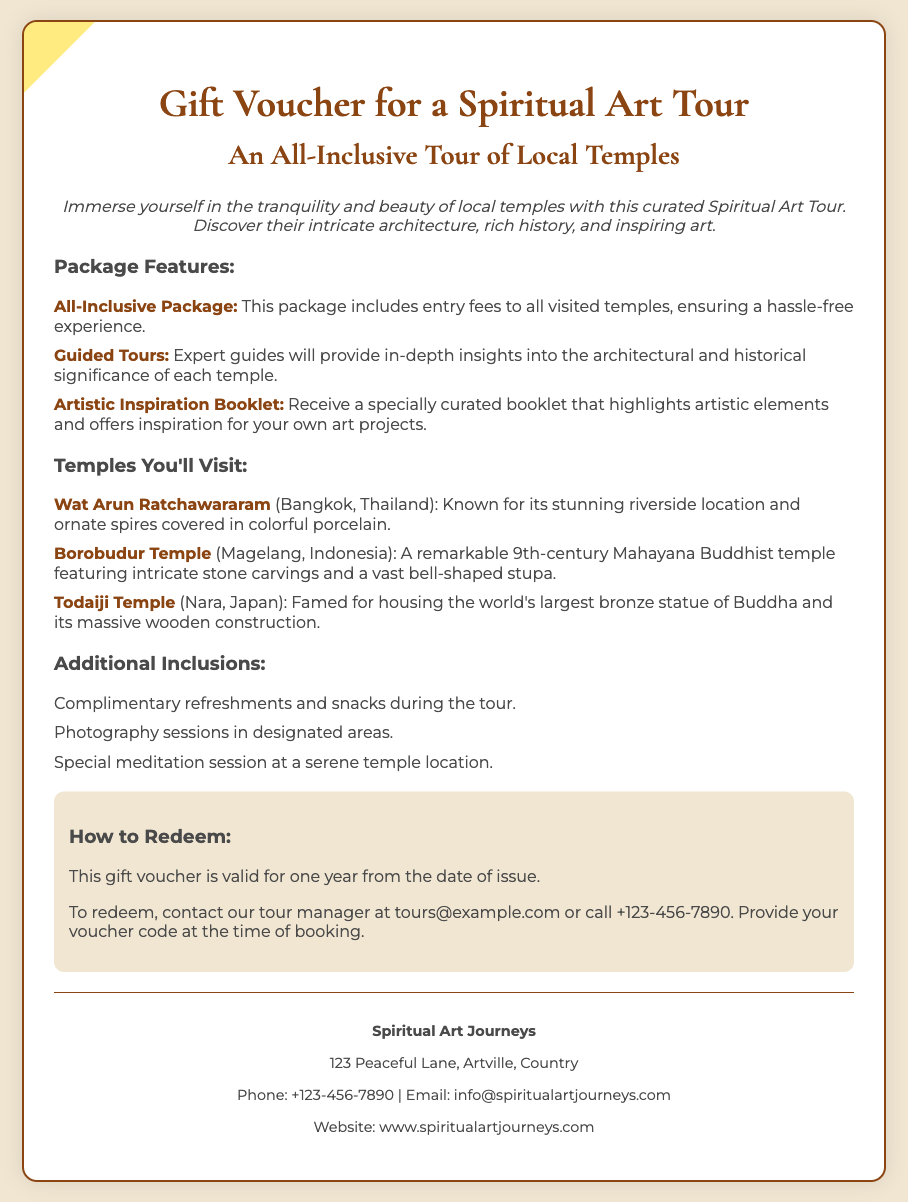What is the title of the gift voucher? The title is prominently displayed at the top of the document, making it easy to identify.
Answer: Gift Voucher for a Spiritual Art Tour What is included in the all-inclusive package? The document lists the features of the package, indicating what is covered for participants.
Answer: Entry fees to all visited temples How many temples will be visited during the tour? The document mentions specific temples included in the tour, providing a clear answer to this question.
Answer: Three Which temple features a vast bell-shaped stupa? The document provides details about each temple's significance, helping to identify unique features.
Answer: Borobudur Temple How long is the gift voucher valid? The document states the validity period of the voucher clearly for potential users.
Answer: One year What type of booklet is included with the tour? The document highlights a specific item provided with the tour package that focuses on artistic inspiration.
Answer: Artistic Inspiration Booklet What is the contact email for tour inquiries? The contact information provides essential details for individuals looking to redeem the voucher or ask questions.
Answer: tours@example.com What kind of session is offered at a serene temple location? The document mentions a unique experience included in the tour, which is highlighted in a specific section.
Answer: Meditation session 